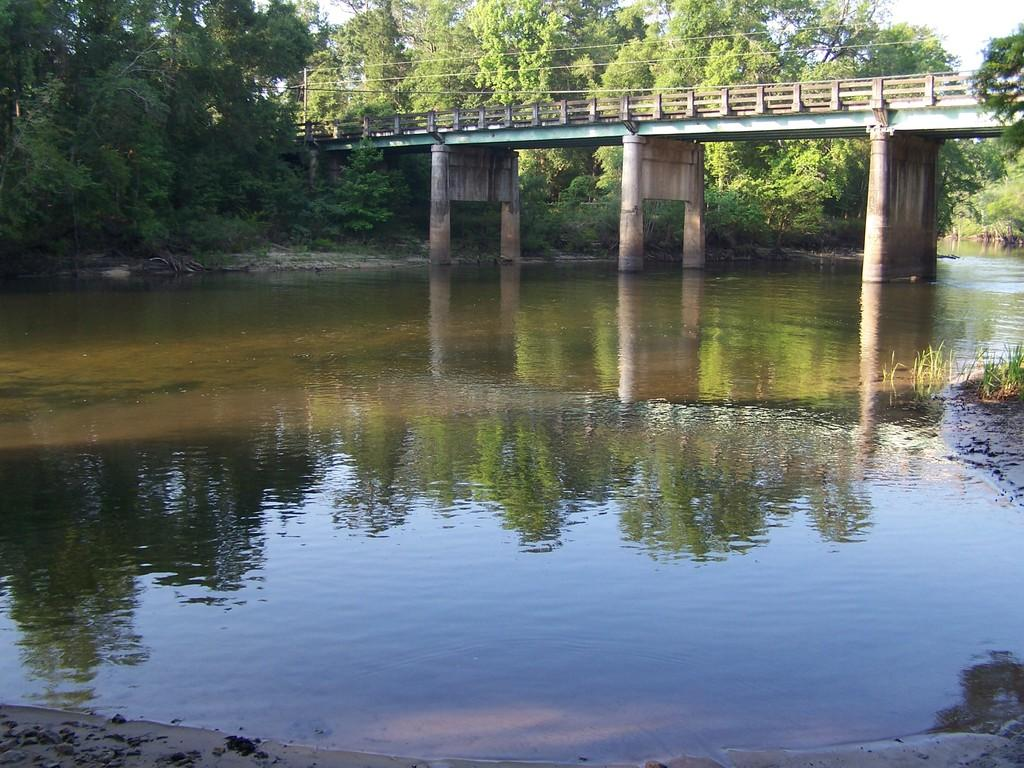What type of vegetation can be seen in the image? There are trees in the image. What else is present in the image besides trees? There are cables, a pole, a bridge, and water under the bridge. What is the reflection of on the water? The reflection of trees and the sky is visible on the water. How does the zipper on the bridge function in the image? There is no zipper present on the bridge in the image. What type of playground equipment can be seen near the bridge? There is no playground equipment visible in the image. 